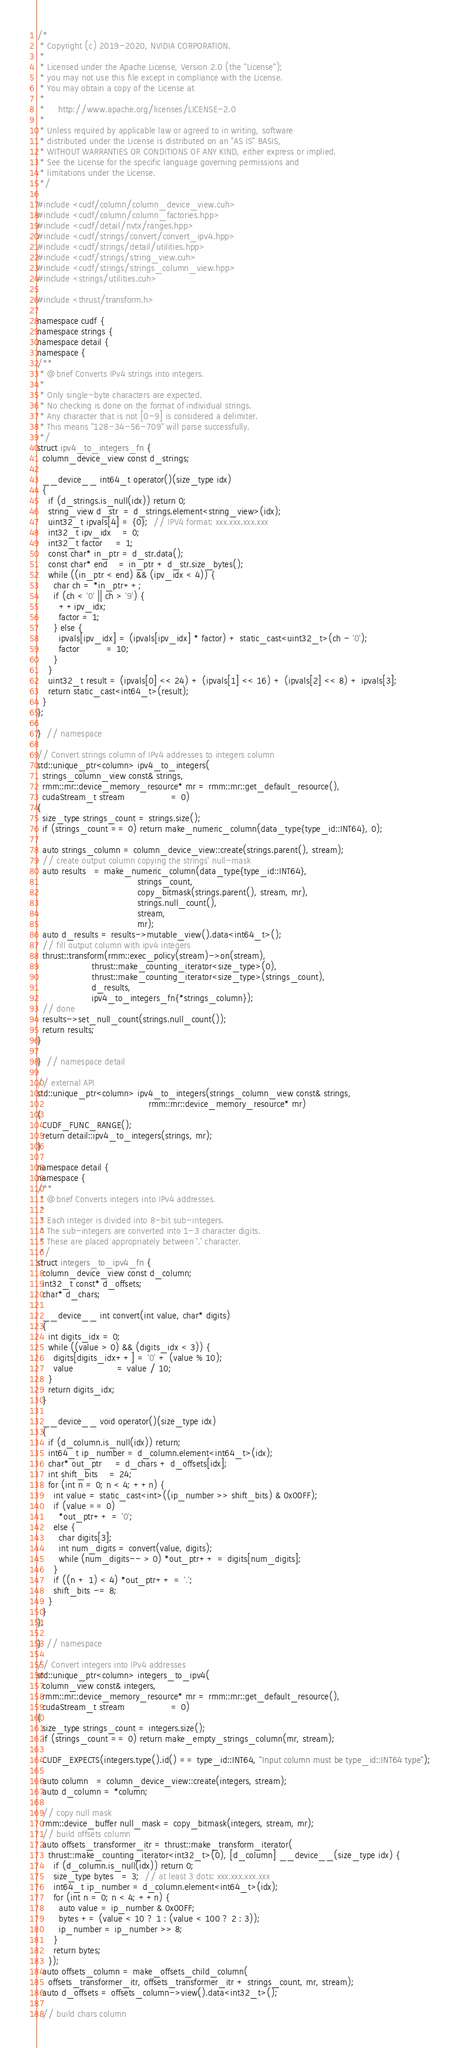Convert code to text. <code><loc_0><loc_0><loc_500><loc_500><_Cuda_>/*
 * Copyright (c) 2019-2020, NVIDIA CORPORATION.
 *
 * Licensed under the Apache License, Version 2.0 (the "License");
 * you may not use this file except in compliance with the License.
 * You may obtain a copy of the License at
 *
 *     http://www.apache.org/licenses/LICENSE-2.0
 *
 * Unless required by applicable law or agreed to in writing, software
 * distributed under the License is distributed on an "AS IS" BASIS,
 * WITHOUT WARRANTIES OR CONDITIONS OF ANY KIND, either express or implied.
 * See the License for the specific language governing permissions and
 * limitations under the License.
 */

#include <cudf/column/column_device_view.cuh>
#include <cudf/column/column_factories.hpp>
#include <cudf/detail/nvtx/ranges.hpp>
#include <cudf/strings/convert/convert_ipv4.hpp>
#include <cudf/strings/detail/utilities.hpp>
#include <cudf/strings/string_view.cuh>
#include <cudf/strings/strings_column_view.hpp>
#include <strings/utilities.cuh>

#include <thrust/transform.h>

namespace cudf {
namespace strings {
namespace detail {
namespace {
/**
 * @brief Converts IPv4 strings into integers.
 *
 * Only single-byte characters are expected.
 * No checking is done on the format of individual strings.
 * Any character that is not [0-9] is considered a delimiter.
 * This means "128-34-56-709" will parse successfully.
 */
struct ipv4_to_integers_fn {
  column_device_view const d_strings;

  __device__ int64_t operator()(size_type idx)
  {
    if (d_strings.is_null(idx)) return 0;
    string_view d_str  = d_strings.element<string_view>(idx);
    uint32_t ipvals[4] = {0};  // IPV4 format: xxx.xxx.xxx.xxx
    int32_t ipv_idx    = 0;
    int32_t factor     = 1;
    const char* in_ptr = d_str.data();
    const char* end    = in_ptr + d_str.size_bytes();
    while ((in_ptr < end) && (ipv_idx < 4)) {
      char ch = *in_ptr++;
      if (ch < '0' || ch > '9') {
        ++ipv_idx;
        factor = 1;
      } else {
        ipvals[ipv_idx] = (ipvals[ipv_idx] * factor) + static_cast<uint32_t>(ch - '0');
        factor          = 10;
      }
    }
    uint32_t result = (ipvals[0] << 24) + (ipvals[1] << 16) + (ipvals[2] << 8) + ipvals[3];
    return static_cast<int64_t>(result);
  }
};

}  // namespace

// Convert strings column of IPv4 addresses to integers column
std::unique_ptr<column> ipv4_to_integers(
  strings_column_view const& strings,
  rmm::mr::device_memory_resource* mr = rmm::mr::get_default_resource(),
  cudaStream_t stream                 = 0)
{
  size_type strings_count = strings.size();
  if (strings_count == 0) return make_numeric_column(data_type{type_id::INT64}, 0);

  auto strings_column = column_device_view::create(strings.parent(), stream);
  // create output column copying the strings' null-mask
  auto results   = make_numeric_column(data_type{type_id::INT64},
                                     strings_count,
                                     copy_bitmask(strings.parent(), stream, mr),
                                     strings.null_count(),
                                     stream,
                                     mr);
  auto d_results = results->mutable_view().data<int64_t>();
  // fill output column with ipv4 integers
  thrust::transform(rmm::exec_policy(stream)->on(stream),
                    thrust::make_counting_iterator<size_type>(0),
                    thrust::make_counting_iterator<size_type>(strings_count),
                    d_results,
                    ipv4_to_integers_fn{*strings_column});
  // done
  results->set_null_count(strings.null_count());
  return results;
}

}  // namespace detail

// external API
std::unique_ptr<column> ipv4_to_integers(strings_column_view const& strings,
                                         rmm::mr::device_memory_resource* mr)
{
  CUDF_FUNC_RANGE();
  return detail::ipv4_to_integers(strings, mr);
}

namespace detail {
namespace {
/**
 * @brief Converts integers into IPv4 addresses.
 *
 * Each integer is divided into 8-bit sub-integers.
 * The sub-integers are converted into 1-3 character digits.
 * These are placed appropriately between '.' character.
 */
struct integers_to_ipv4_fn {
  column_device_view const d_column;
  int32_t const* d_offsets;
  char* d_chars;

  __device__ int convert(int value, char* digits)
  {
    int digits_idx = 0;
    while ((value > 0) && (digits_idx < 3)) {
      digits[digits_idx++] = '0' + (value % 10);
      value                = value / 10;
    }
    return digits_idx;
  }

  __device__ void operator()(size_type idx)
  {
    if (d_column.is_null(idx)) return;
    int64_t ip_number = d_column.element<int64_t>(idx);
    char* out_ptr     = d_chars + d_offsets[idx];
    int shift_bits    = 24;
    for (int n = 0; n < 4; ++n) {
      int value = static_cast<int>((ip_number >> shift_bits) & 0x00FF);
      if (value == 0)
        *out_ptr++ = '0';
      else {
        char digits[3];
        int num_digits = convert(value, digits);
        while (num_digits-- > 0) *out_ptr++ = digits[num_digits];
      }
      if ((n + 1) < 4) *out_ptr++ = '.';
      shift_bits -= 8;
    }
  }
};

}  // namespace

// Convert integers into IPv4 addresses
std::unique_ptr<column> integers_to_ipv4(
  column_view const& integers,
  rmm::mr::device_memory_resource* mr = rmm::mr::get_default_resource(),
  cudaStream_t stream                 = 0)
{
  size_type strings_count = integers.size();
  if (strings_count == 0) return make_empty_strings_column(mr, stream);

  CUDF_EXPECTS(integers.type().id() == type_id::INT64, "Input column must be type_id::INT64 type");

  auto column   = column_device_view::create(integers, stream);
  auto d_column = *column;

  // copy null mask
  rmm::device_buffer null_mask = copy_bitmask(integers, stream, mr);
  // build offsets column
  auto offsets_transformer_itr = thrust::make_transform_iterator(
    thrust::make_counting_iterator<int32_t>(0), [d_column] __device__(size_type idx) {
      if (d_column.is_null(idx)) return 0;
      size_type bytes   = 3;  // at least 3 dots: xxx.xxx.xxx.xxx
      int64_t ip_number = d_column.element<int64_t>(idx);
      for (int n = 0; n < 4; ++n) {
        auto value = ip_number & 0x00FF;
        bytes += (value < 10 ? 1 : (value < 100 ? 2 : 3));
        ip_number = ip_number >> 8;
      }
      return bytes;
    });
  auto offsets_column = make_offsets_child_column(
    offsets_transformer_itr, offsets_transformer_itr + strings_count, mr, stream);
  auto d_offsets = offsets_column->view().data<int32_t>();

  // build chars column</code> 